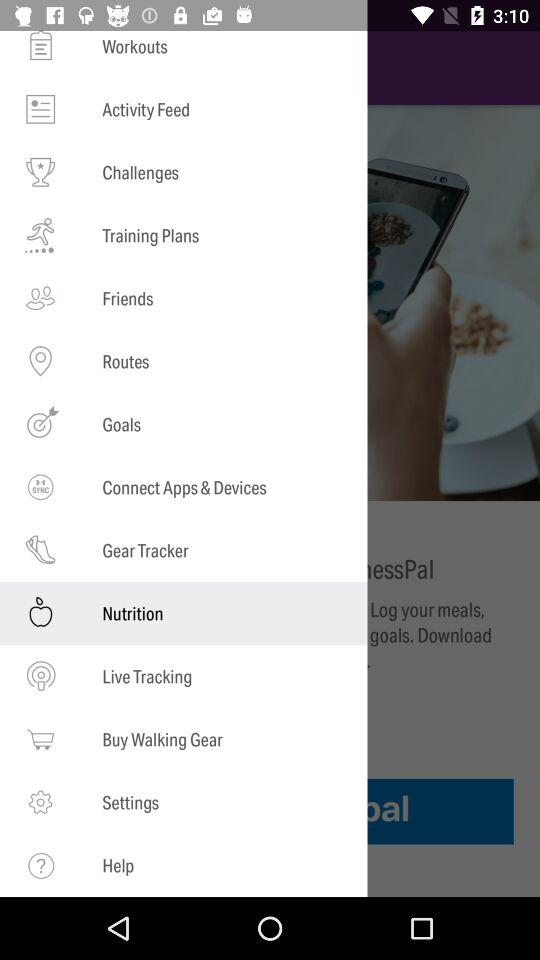How many notifications are there in "Settings"?
When the provided information is insufficient, respond with <no answer>. <no answer> 